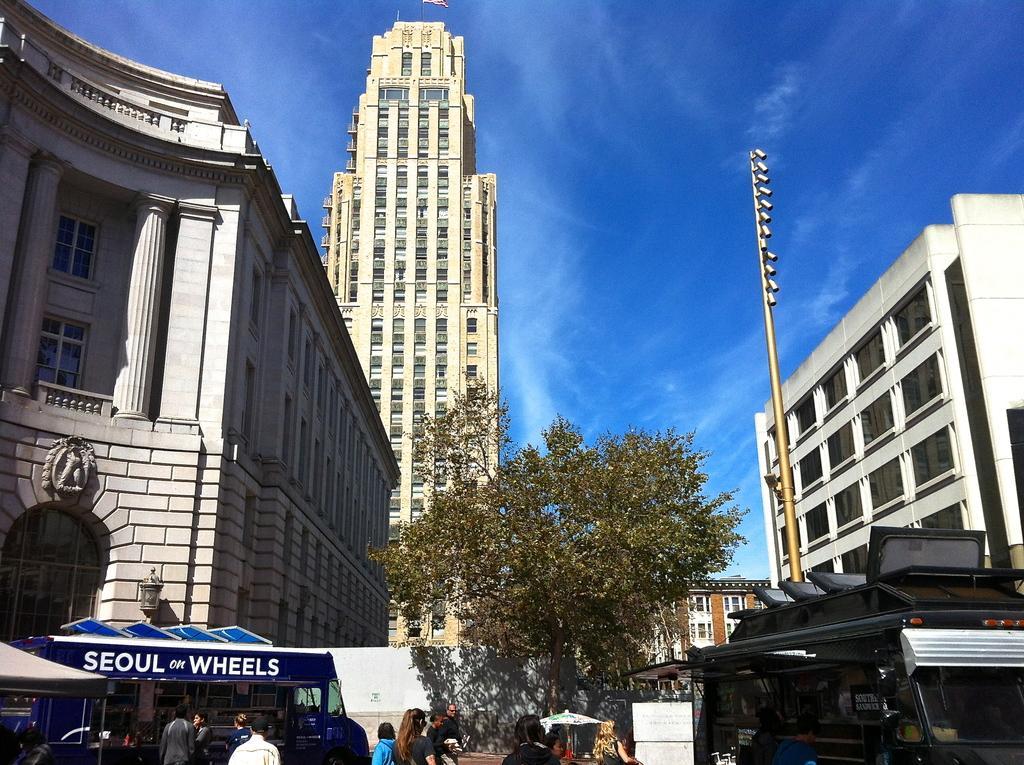Please provide a concise description of this image. In the picture we can see some persons walking, there are some vehicles, trees and in the background of the picture there are some buildings and clear sky. 